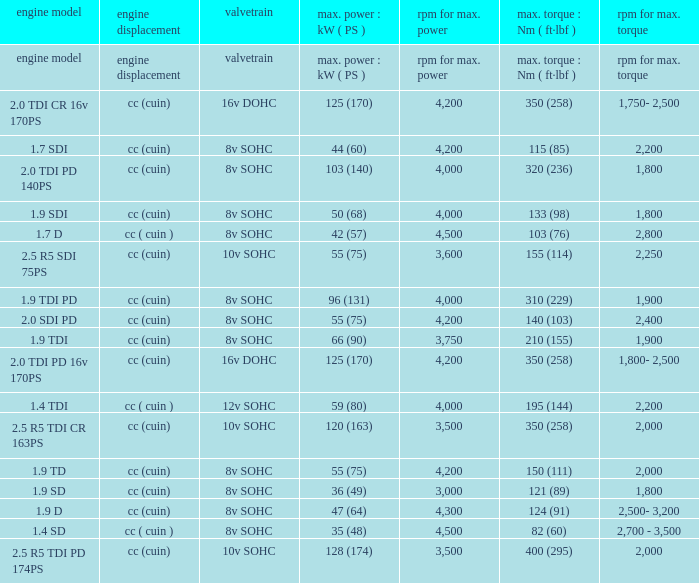What is the valvetrain with an engine model that is engine model? Valvetrain. Would you be able to parse every entry in this table? {'header': ['engine model', 'engine displacement', 'valvetrain', 'max. power : kW ( PS )', 'rpm for max. power', 'max. torque : Nm ( ft·lbf )', 'rpm for max. torque'], 'rows': [['engine model', 'engine displacement', 'valvetrain', 'max. power : kW ( PS )', 'rpm for max. power', 'max. torque : Nm ( ft·lbf )', 'rpm for max. torque'], ['2.0 TDI CR 16v 170PS', 'cc (cuin)', '16v DOHC', '125 (170)', '4,200', '350 (258)', '1,750- 2,500'], ['1.7 SDI', 'cc (cuin)', '8v SOHC', '44 (60)', '4,200', '115 (85)', '2,200'], ['2.0 TDI PD 140PS', 'cc (cuin)', '8v SOHC', '103 (140)', '4,000', '320 (236)', '1,800'], ['1.9 SDI', 'cc (cuin)', '8v SOHC', '50 (68)', '4,000', '133 (98)', '1,800'], ['1.7 D', 'cc ( cuin )', '8v SOHC', '42 (57)', '4,500', '103 (76)', '2,800'], ['2.5 R5 SDI 75PS', 'cc (cuin)', '10v SOHC', '55 (75)', '3,600', '155 (114)', '2,250'], ['1.9 TDI PD', 'cc (cuin)', '8v SOHC', '96 (131)', '4,000', '310 (229)', '1,900'], ['2.0 SDI PD', 'cc (cuin)', '8v SOHC', '55 (75)', '4,200', '140 (103)', '2,400'], ['1.9 TDI', 'cc (cuin)', '8v SOHC', '66 (90)', '3,750', '210 (155)', '1,900'], ['2.0 TDI PD 16v 170PS', 'cc (cuin)', '16v DOHC', '125 (170)', '4,200', '350 (258)', '1,800- 2,500'], ['1.4 TDI', 'cc ( cuin )', '12v SOHC', '59 (80)', '4,000', '195 (144)', '2,200'], ['2.5 R5 TDI CR 163PS', 'cc (cuin)', '10v SOHC', '120 (163)', '3,500', '350 (258)', '2,000'], ['1.9 TD', 'cc (cuin)', '8v SOHC', '55 (75)', '4,200', '150 (111)', '2,000'], ['1.9 SD', 'cc (cuin)', '8v SOHC', '36 (49)', '3,000', '121 (89)', '1,800'], ['1.9 D', 'cc (cuin)', '8v SOHC', '47 (64)', '4,300', '124 (91)', '2,500- 3,200'], ['1.4 SD', 'cc ( cuin )', '8v SOHC', '35 (48)', '4,500', '82 (60)', '2,700 - 3,500'], ['2.5 R5 TDI PD 174PS', 'cc (cuin)', '10v SOHC', '128 (174)', '3,500', '400 (295)', '2,000']]} 